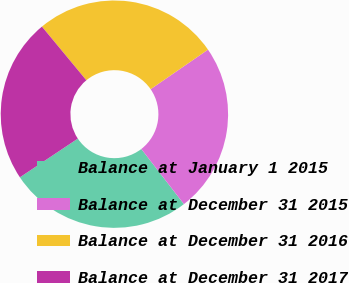Convert chart to OTSL. <chart><loc_0><loc_0><loc_500><loc_500><pie_chart><fcel>Balance at January 1 2015<fcel>Balance at December 31 2015<fcel>Balance at December 31 2016<fcel>Balance at December 31 2017<nl><fcel>26.1%<fcel>24.14%<fcel>26.4%<fcel>23.37%<nl></chart> 